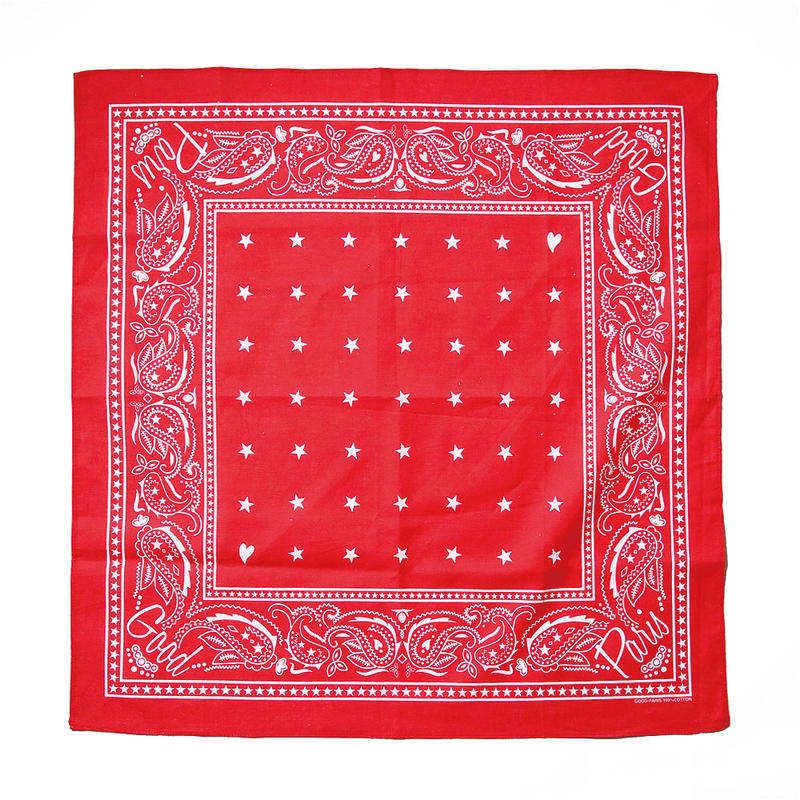What is the approximate size of the bandana based on the standard dimensions of such an accessory? The image itself does not provide a scale for exact measurement, but typical bandana dimensions are generally around 22 inches by 22 inches (approximately 56 cm by 56 cm). Observing the fully spread and square-shaped appearance in the image, it is reasonable to assume that this bandana closely aligns with the standard dimensions. 